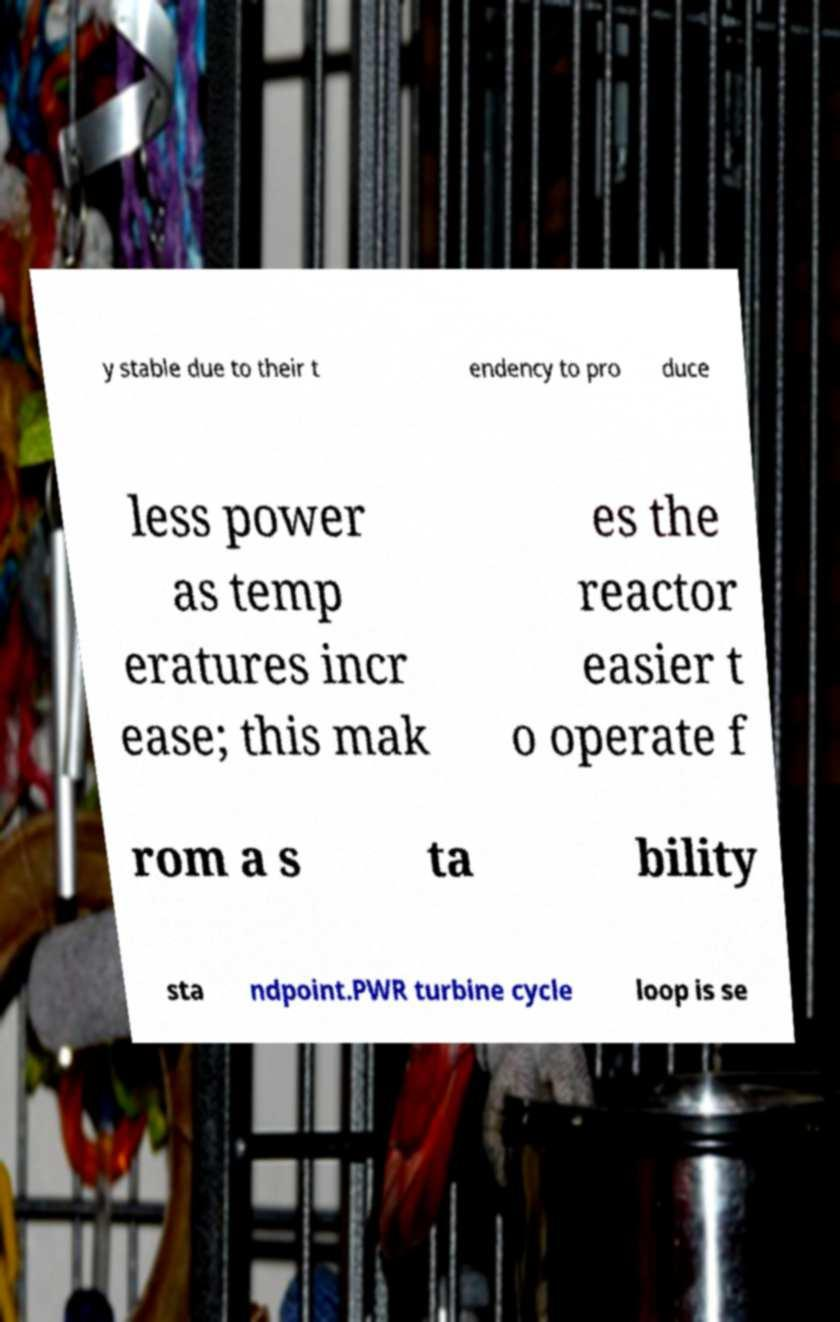Please read and relay the text visible in this image. What does it say? y stable due to their t endency to pro duce less power as temp eratures incr ease; this mak es the reactor easier t o operate f rom a s ta bility sta ndpoint.PWR turbine cycle loop is se 